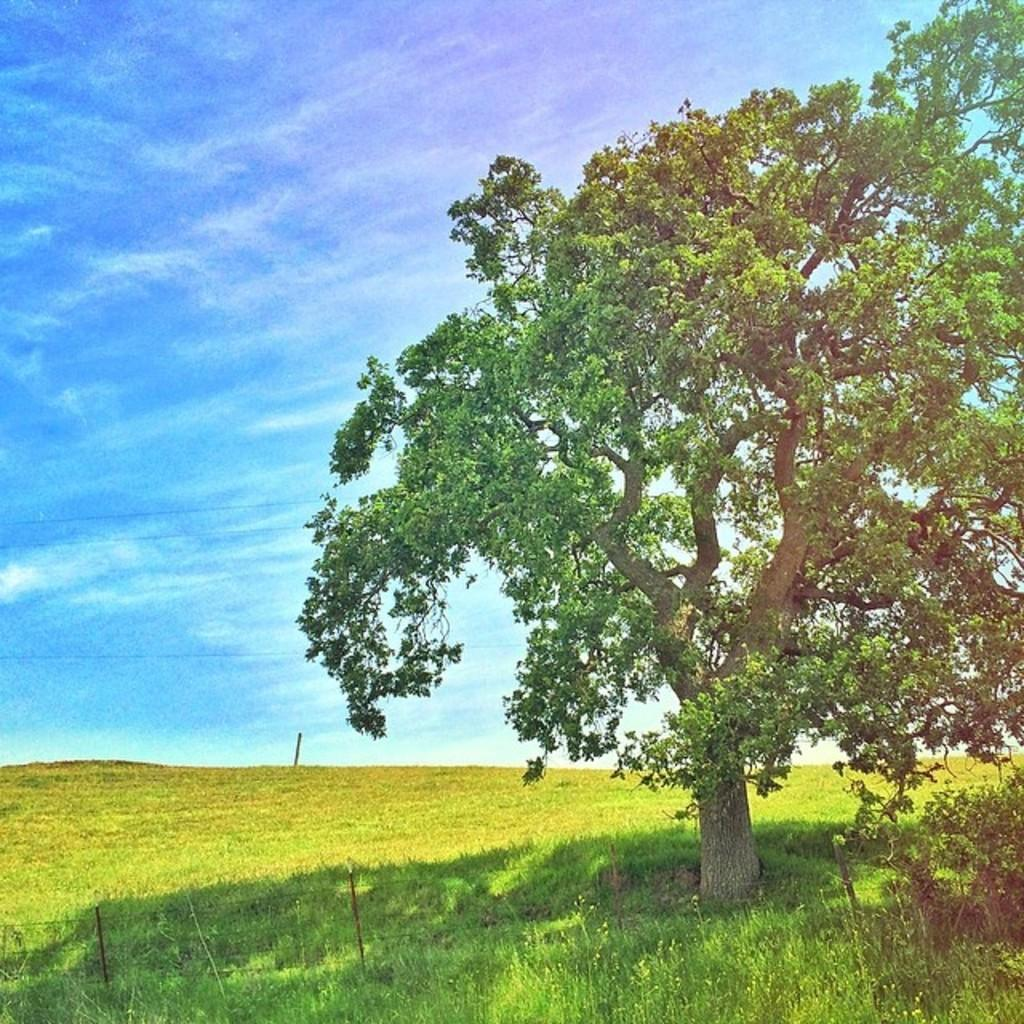What type of vegetation is present in the image? There is a tree, a plant, and grass in the image. What color is the sky in the image? The sky is blue in the image. What other structures can be seen in the image? There is a small pole and fence wires in the image. Where is the faucet located in the image? There is no faucet present in the image. What type of support does the van provide in the image? There is no van present in the image, so it cannot provide any support. 